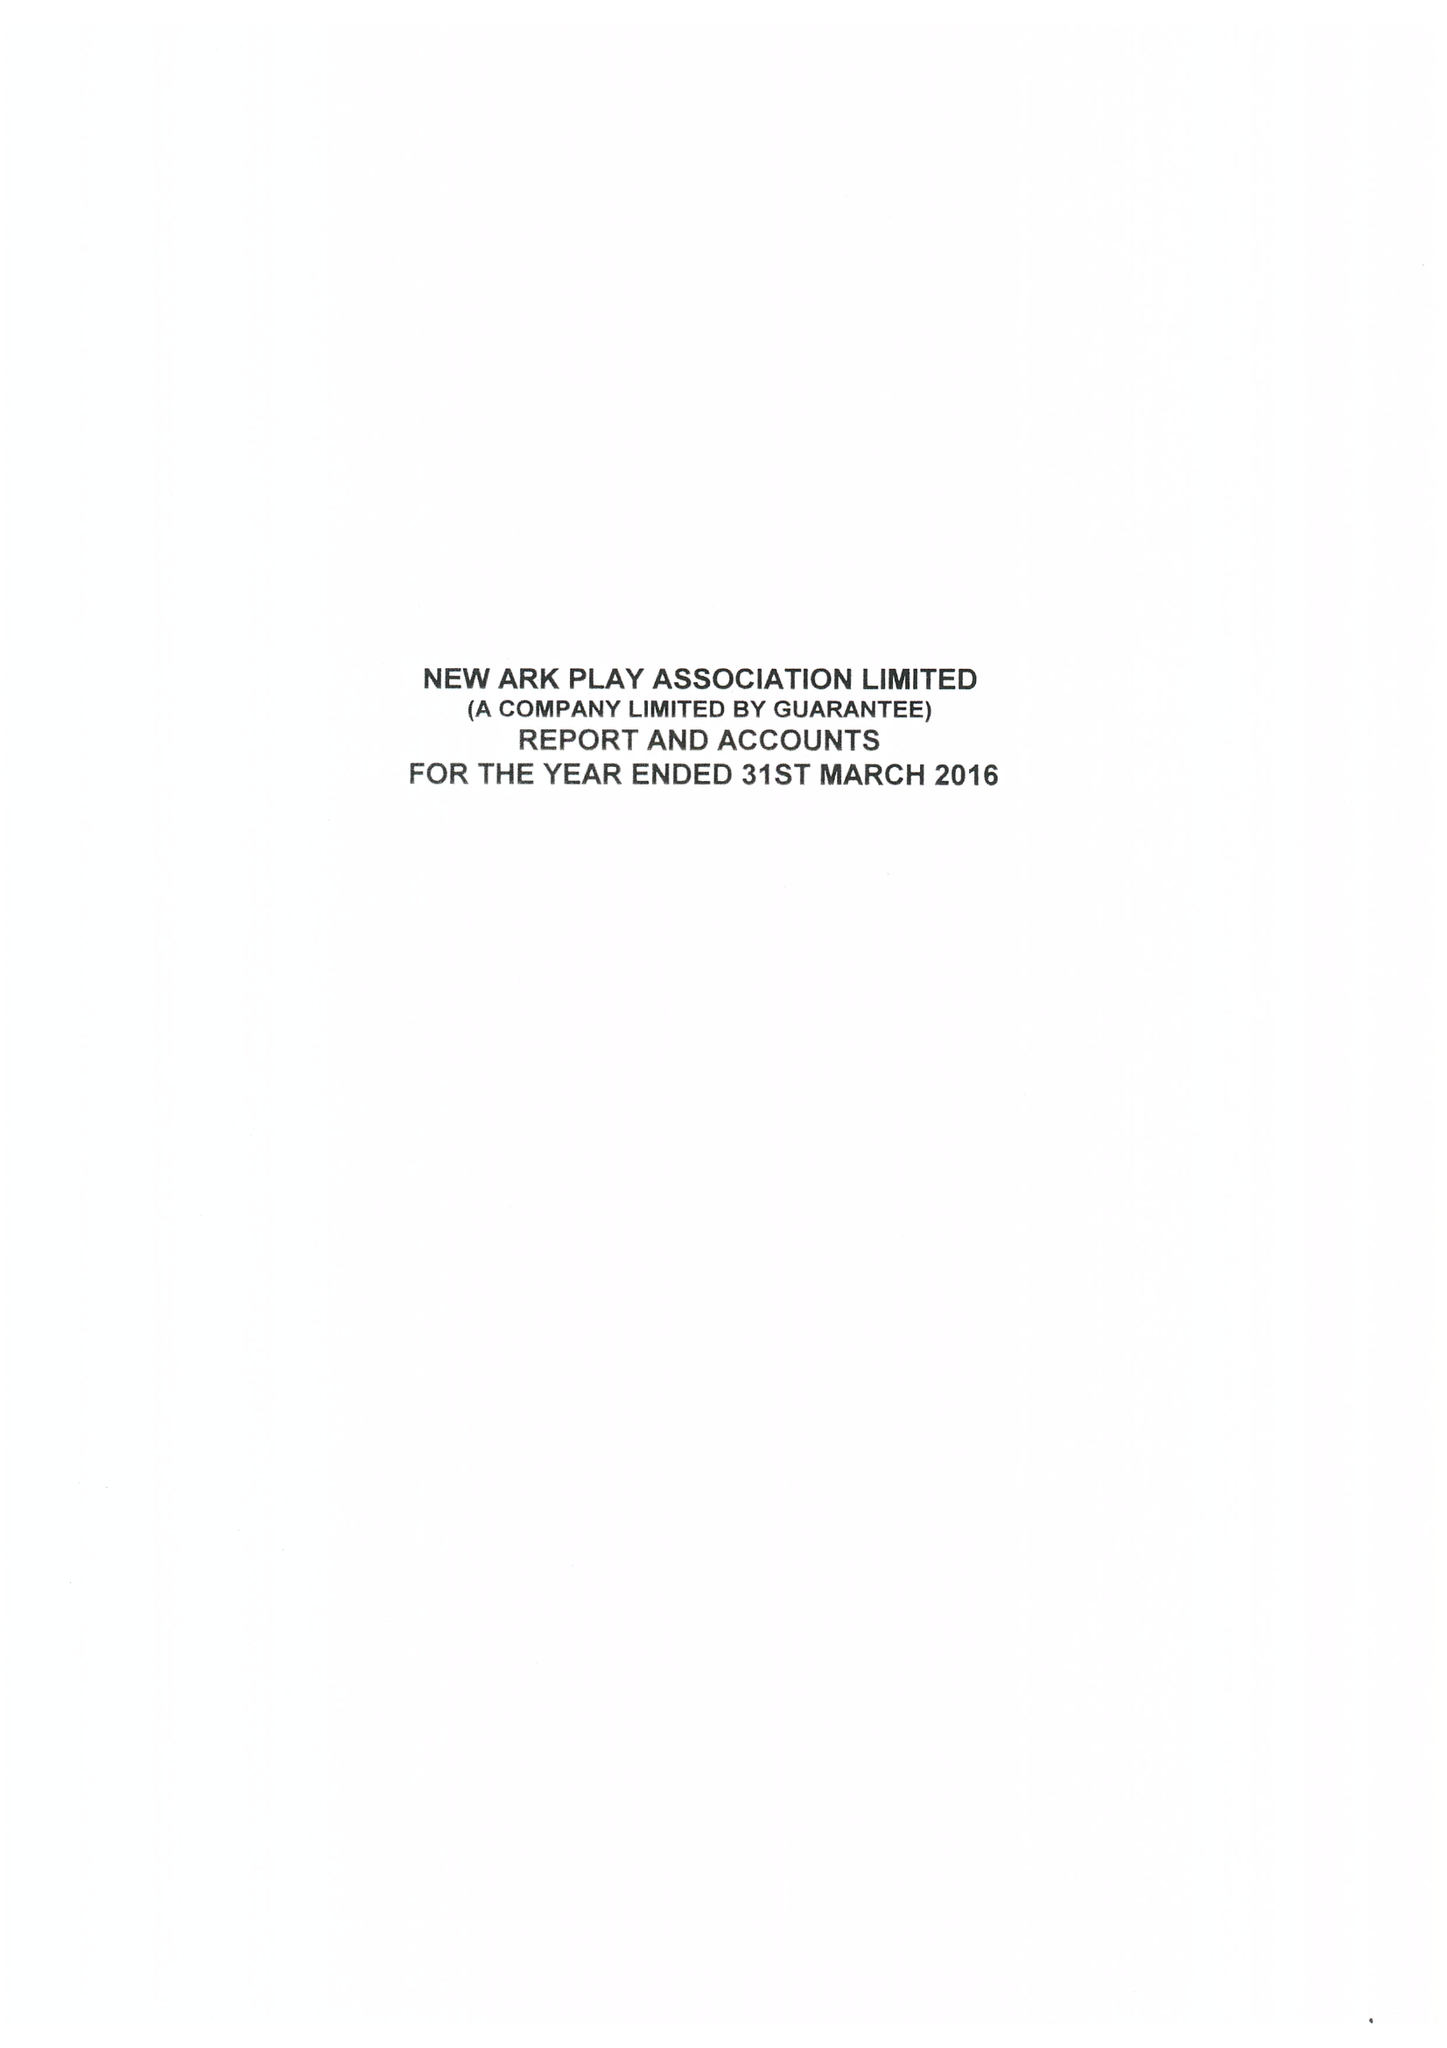What is the value for the address__postcode?
Answer the question using a single word or phrase. PE1 4PA 